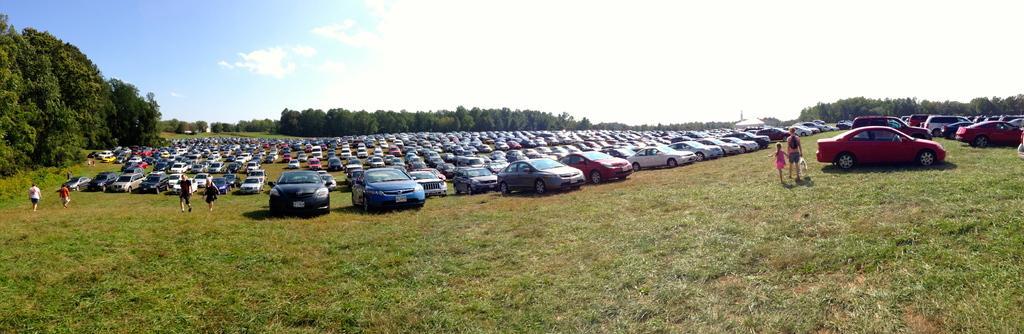Can you describe this image briefly? This picture might be taken from outside of the city and it is sunny. in this image, on the right side, we can see some cars which are placed on the road, we can see two people are walking on the grass. On the left side there are group of people walking on the grass, trees. In the background, we can see some cars, trees. On the top, we can see a sky, at the bottom, we can see a grass. 